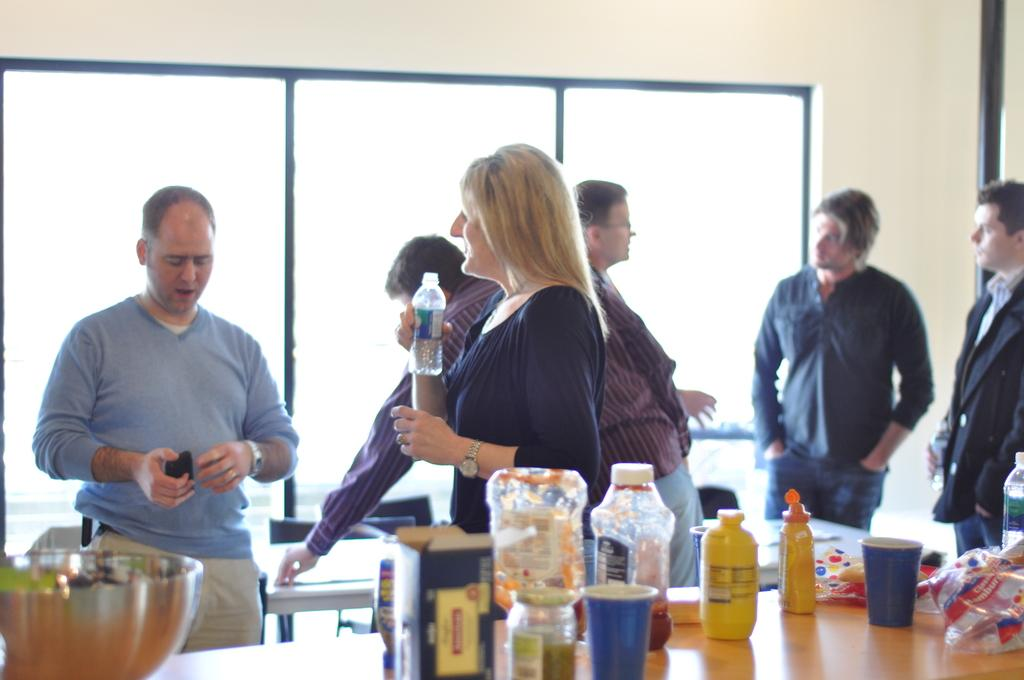What can be seen in the image involving a group of people? There is a group of people in the image. What is the woman holding in the image? The woman is holding a water bottle. What piece of furniture is present in the image? There is a table in the image. What condiment is present on the table? A ketchup bottle is present on the table. What else can be found on the table in the image? There are bottles around on the table. Is there any rain visible in the image? No, there is no rain visible in the image. What type of wire is being used by the people in the image? There is no wire present in the image; it only features a group of people, a table, and various bottles and containers. 